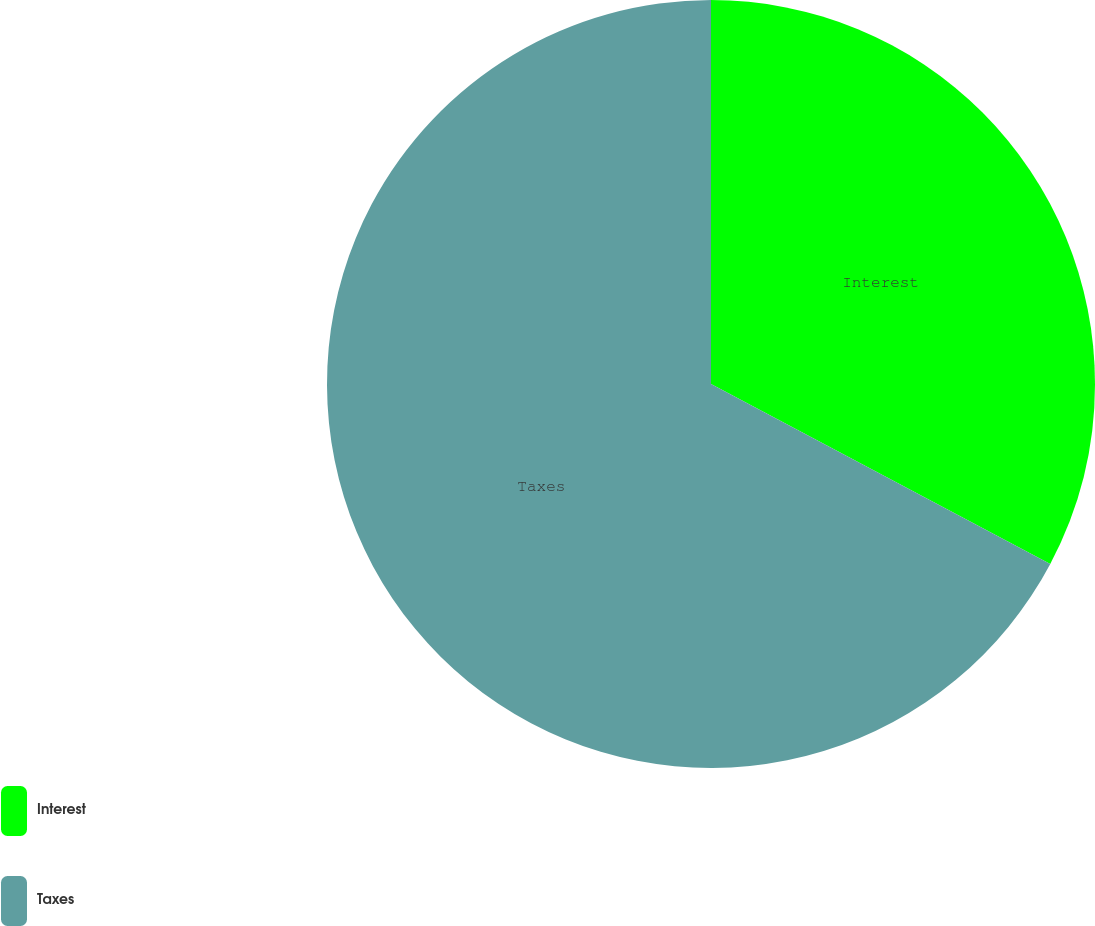Convert chart. <chart><loc_0><loc_0><loc_500><loc_500><pie_chart><fcel>Interest<fcel>Taxes<nl><fcel>32.76%<fcel>67.24%<nl></chart> 